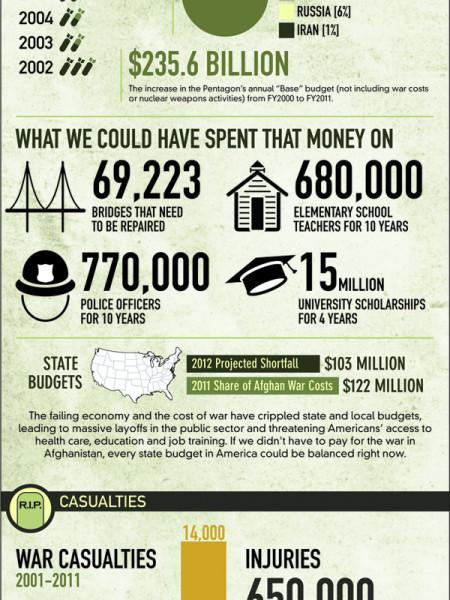How many elementary school teachers could have been paid for 10 years?
Answer the question with a short phrase. 680,000 How many bridges needed repairing? 69,223 On how many Police officers could the $ 235.6 billion be spent? 770,000 What is the increase in Pentagon annual base budget? $235.6 billion How many better ways to spend $ 235.6 billion, are mentioned here? 4 How many University scholarships could be given for four years? 15 million 